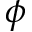Convert formula to latex. <formula><loc_0><loc_0><loc_500><loc_500>\phi</formula> 